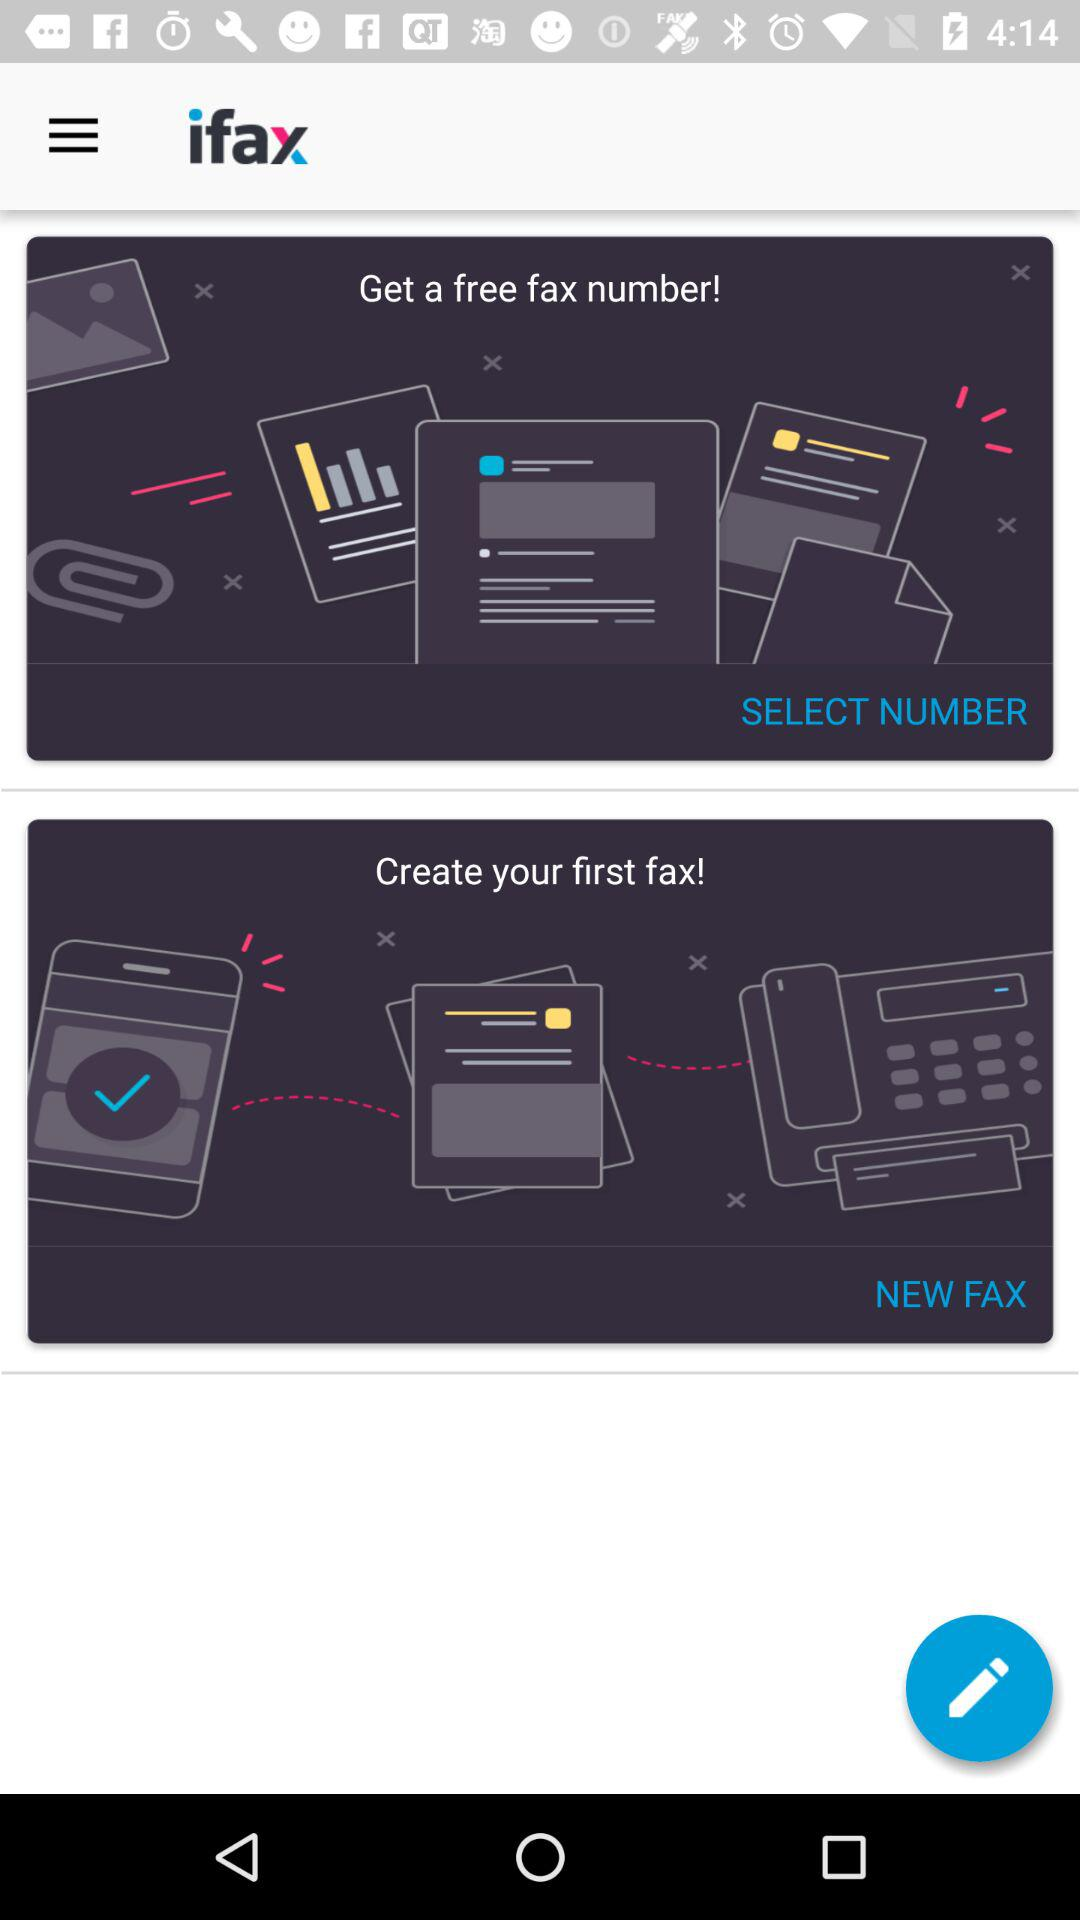Who is this application powered by?
When the provided information is insufficient, respond with <no answer>. <no answer> 